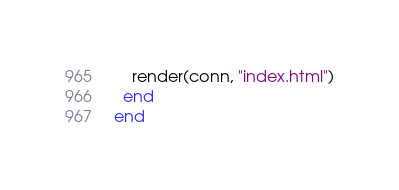<code> <loc_0><loc_0><loc_500><loc_500><_Elixir_>    render(conn, "index.html")
  end
end
</code> 